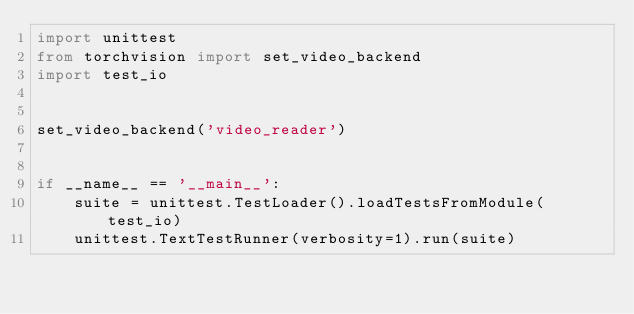Convert code to text. <code><loc_0><loc_0><loc_500><loc_500><_Python_>import unittest
from torchvision import set_video_backend
import test_io


set_video_backend('video_reader')


if __name__ == '__main__':
    suite = unittest.TestLoader().loadTestsFromModule(test_io)
    unittest.TextTestRunner(verbosity=1).run(suite)
</code> 